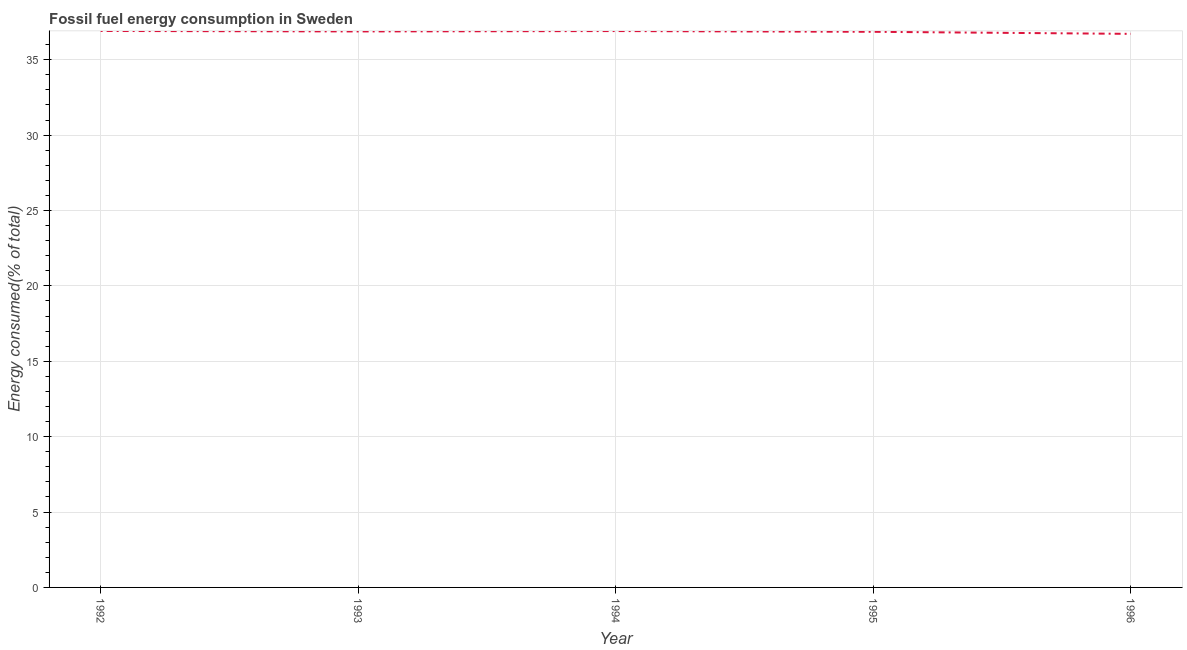What is the fossil fuel energy consumption in 1994?
Provide a short and direct response. 36.9. Across all years, what is the maximum fossil fuel energy consumption?
Make the answer very short. 36.91. Across all years, what is the minimum fossil fuel energy consumption?
Ensure brevity in your answer.  36.72. What is the sum of the fossil fuel energy consumption?
Your response must be concise. 184.26. What is the difference between the fossil fuel energy consumption in 1992 and 1995?
Provide a succinct answer. 0.06. What is the average fossil fuel energy consumption per year?
Give a very brief answer. 36.85. What is the median fossil fuel energy consumption?
Ensure brevity in your answer.  36.88. In how many years, is the fossil fuel energy consumption greater than 9 %?
Provide a short and direct response. 5. Do a majority of the years between 1993 and 1992 (inclusive) have fossil fuel energy consumption greater than 15 %?
Provide a succinct answer. No. What is the ratio of the fossil fuel energy consumption in 1993 to that in 1995?
Give a very brief answer. 1. Is the fossil fuel energy consumption in 1994 less than that in 1995?
Keep it short and to the point. No. What is the difference between the highest and the second highest fossil fuel energy consumption?
Keep it short and to the point. 0.01. Is the sum of the fossil fuel energy consumption in 1995 and 1996 greater than the maximum fossil fuel energy consumption across all years?
Keep it short and to the point. Yes. What is the difference between the highest and the lowest fossil fuel energy consumption?
Your answer should be very brief. 0.19. In how many years, is the fossil fuel energy consumption greater than the average fossil fuel energy consumption taken over all years?
Your answer should be compact. 4. How many lines are there?
Keep it short and to the point. 1. Does the graph contain any zero values?
Your answer should be compact. No. What is the title of the graph?
Provide a succinct answer. Fossil fuel energy consumption in Sweden. What is the label or title of the Y-axis?
Your response must be concise. Energy consumed(% of total). What is the Energy consumed(% of total) in 1992?
Provide a succinct answer. 36.91. What is the Energy consumed(% of total) of 1993?
Offer a terse response. 36.88. What is the Energy consumed(% of total) in 1994?
Provide a short and direct response. 36.9. What is the Energy consumed(% of total) in 1995?
Provide a succinct answer. 36.85. What is the Energy consumed(% of total) of 1996?
Give a very brief answer. 36.72. What is the difference between the Energy consumed(% of total) in 1992 and 1993?
Ensure brevity in your answer.  0.03. What is the difference between the Energy consumed(% of total) in 1992 and 1994?
Your response must be concise. 0.01. What is the difference between the Energy consumed(% of total) in 1992 and 1995?
Make the answer very short. 0.06. What is the difference between the Energy consumed(% of total) in 1992 and 1996?
Provide a short and direct response. 0.19. What is the difference between the Energy consumed(% of total) in 1993 and 1994?
Provide a short and direct response. -0.03. What is the difference between the Energy consumed(% of total) in 1993 and 1995?
Offer a terse response. 0.02. What is the difference between the Energy consumed(% of total) in 1993 and 1996?
Your response must be concise. 0.16. What is the difference between the Energy consumed(% of total) in 1994 and 1995?
Provide a succinct answer. 0.05. What is the difference between the Energy consumed(% of total) in 1994 and 1996?
Offer a terse response. 0.19. What is the difference between the Energy consumed(% of total) in 1995 and 1996?
Your response must be concise. 0.14. What is the ratio of the Energy consumed(% of total) in 1992 to that in 1993?
Give a very brief answer. 1. What is the ratio of the Energy consumed(% of total) in 1993 to that in 1994?
Offer a very short reply. 1. What is the ratio of the Energy consumed(% of total) in 1994 to that in 1995?
Your answer should be compact. 1. What is the ratio of the Energy consumed(% of total) in 1994 to that in 1996?
Your answer should be compact. 1. 